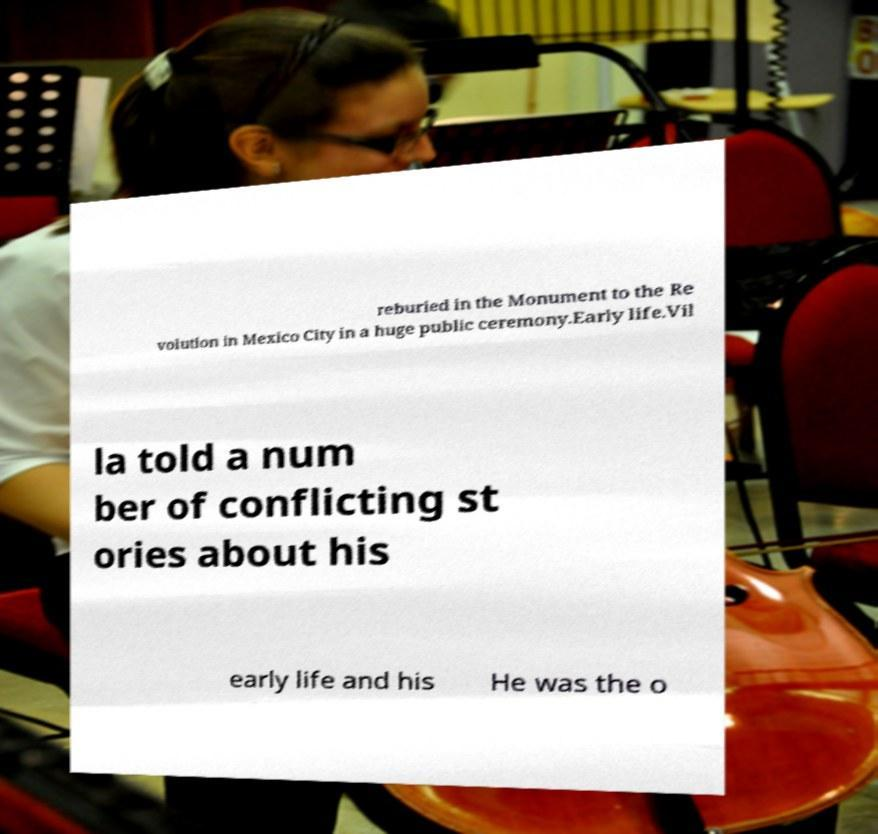What messages or text are displayed in this image? I need them in a readable, typed format. reburied in the Monument to the Re volution in Mexico City in a huge public ceremony.Early life.Vil la told a num ber of conflicting st ories about his early life and his He was the o 